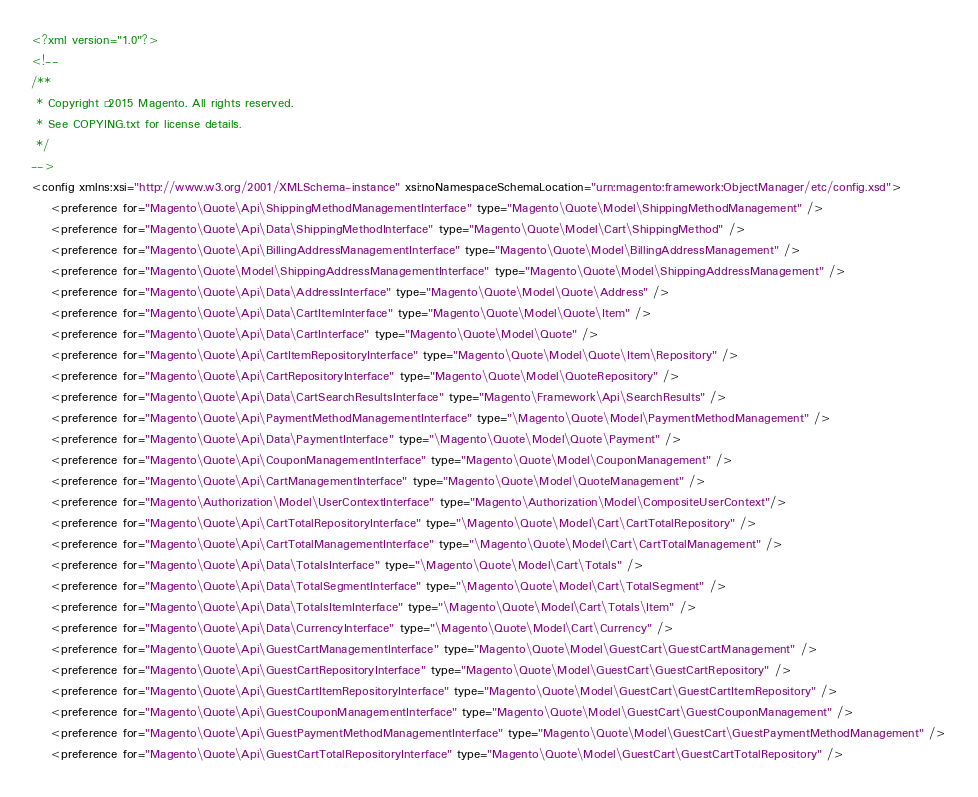Convert code to text. <code><loc_0><loc_0><loc_500><loc_500><_XML_><?xml version="1.0"?>
<!--
/**
 * Copyright © 2015 Magento. All rights reserved.
 * See COPYING.txt for license details.
 */
-->
<config xmlns:xsi="http://www.w3.org/2001/XMLSchema-instance" xsi:noNamespaceSchemaLocation="urn:magento:framework:ObjectManager/etc/config.xsd">
    <preference for="Magento\Quote\Api\ShippingMethodManagementInterface" type="Magento\Quote\Model\ShippingMethodManagement" />
    <preference for="Magento\Quote\Api\Data\ShippingMethodInterface" type="Magento\Quote\Model\Cart\ShippingMethod" />
    <preference for="Magento\Quote\Api\BillingAddressManagementInterface" type="Magento\Quote\Model\BillingAddressManagement" />
    <preference for="Magento\Quote\Model\ShippingAddressManagementInterface" type="Magento\Quote\Model\ShippingAddressManagement" />
    <preference for="Magento\Quote\Api\Data\AddressInterface" type="Magento\Quote\Model\Quote\Address" />
    <preference for="Magento\Quote\Api\Data\CartItemInterface" type="Magento\Quote\Model\Quote\Item" />
    <preference for="Magento\Quote\Api\Data\CartInterface" type="Magento\Quote\Model\Quote" />
    <preference for="Magento\Quote\Api\CartItemRepositoryInterface" type="Magento\Quote\Model\Quote\Item\Repository" />
    <preference for="Magento\Quote\Api\CartRepositoryInterface" type="Magento\Quote\Model\QuoteRepository" />
    <preference for="Magento\Quote\Api\Data\CartSearchResultsInterface" type="Magento\Framework\Api\SearchResults" />
    <preference for="Magento\Quote\Api\PaymentMethodManagementInterface" type="\Magento\Quote\Model\PaymentMethodManagement" />
    <preference for="Magento\Quote\Api\Data\PaymentInterface" type="\Magento\Quote\Model\Quote\Payment" />
    <preference for="Magento\Quote\Api\CouponManagementInterface" type="Magento\Quote\Model\CouponManagement" />
    <preference for="Magento\Quote\Api\CartManagementInterface" type="Magento\Quote\Model\QuoteManagement" />
    <preference for="Magento\Authorization\Model\UserContextInterface" type="Magento\Authorization\Model\CompositeUserContext"/>
    <preference for="Magento\Quote\Api\CartTotalRepositoryInterface" type="\Magento\Quote\Model\Cart\CartTotalRepository" />
    <preference for="Magento\Quote\Api\CartTotalManagementInterface" type="\Magento\Quote\Model\Cart\CartTotalManagement" />
    <preference for="Magento\Quote\Api\Data\TotalsInterface" type="\Magento\Quote\Model\Cart\Totals" />
    <preference for="Magento\Quote\Api\Data\TotalSegmentInterface" type="\Magento\Quote\Model\Cart\TotalSegment" />
    <preference for="Magento\Quote\Api\Data\TotalsItemInterface" type="\Magento\Quote\Model\Cart\Totals\Item" />
    <preference for="Magento\Quote\Api\Data\CurrencyInterface" type="\Magento\Quote\Model\Cart\Currency" />
    <preference for="Magento\Quote\Api\GuestCartManagementInterface" type="Magento\Quote\Model\GuestCart\GuestCartManagement" />
    <preference for="Magento\Quote\Api\GuestCartRepositoryInterface" type="Magento\Quote\Model\GuestCart\GuestCartRepository" />
    <preference for="Magento\Quote\Api\GuestCartItemRepositoryInterface" type="Magento\Quote\Model\GuestCart\GuestCartItemRepository" />
    <preference for="Magento\Quote\Api\GuestCouponManagementInterface" type="Magento\Quote\Model\GuestCart\GuestCouponManagement" />
    <preference for="Magento\Quote\Api\GuestPaymentMethodManagementInterface" type="Magento\Quote\Model\GuestCart\GuestPaymentMethodManagement" />
    <preference for="Magento\Quote\Api\GuestCartTotalRepositoryInterface" type="Magento\Quote\Model\GuestCart\GuestCartTotalRepository" /></code> 